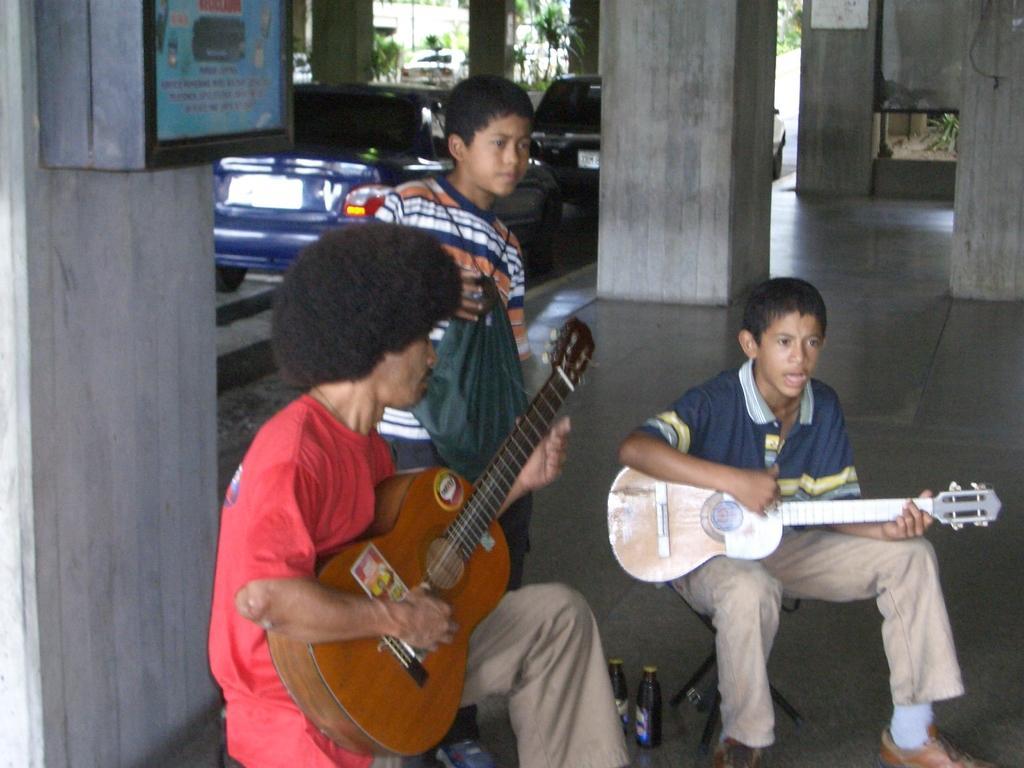Could you give a brief overview of what you see in this image? In this picture there is a man and a boy playing guitar. There is another boy who is holding a cover. There are cars. There is a pillar and bottles. 